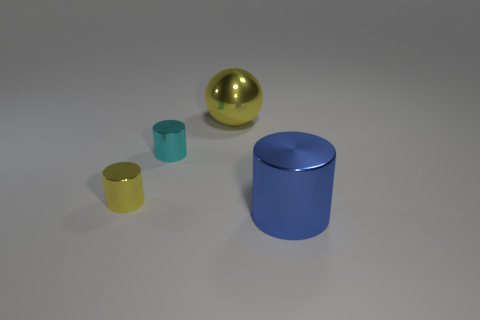How many yellow objects are in front of the large thing left of the big blue cylinder? In front of the object to the left of the large blue cylinder, there is one small yellow cup. It's the only yellow object in that specific area. 